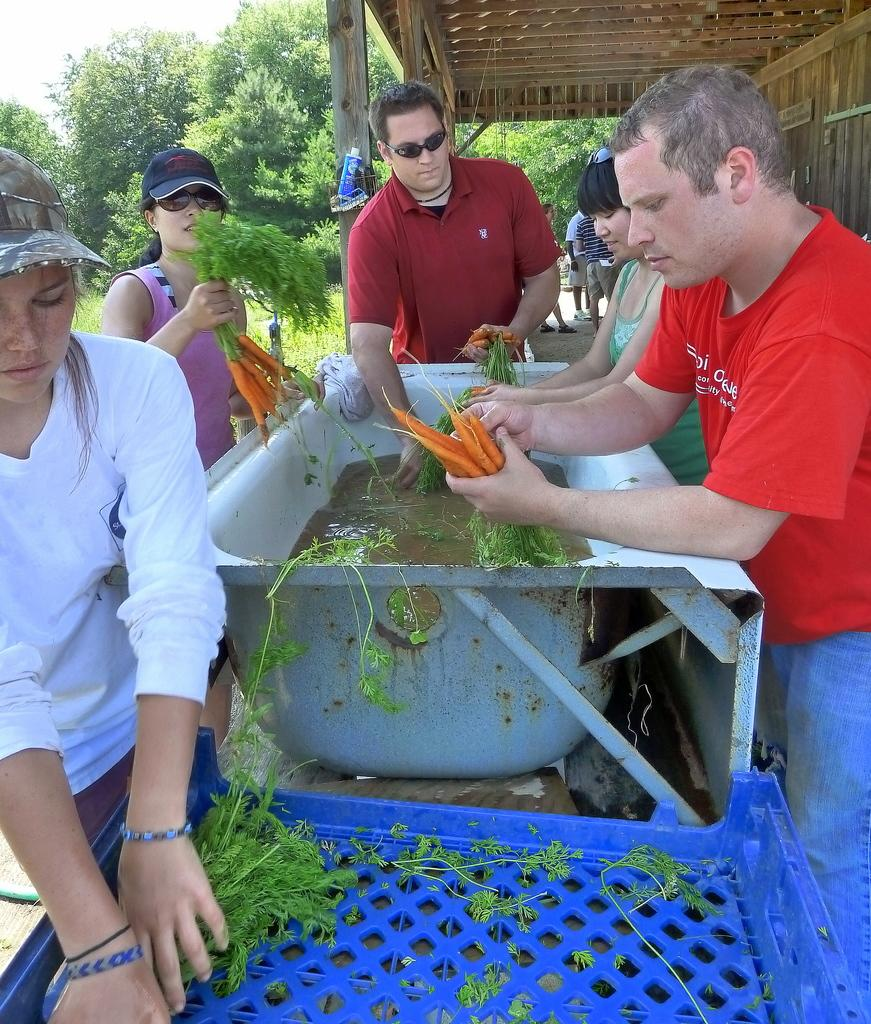Who or what is present in the image? There are people in the image. What are some of the people holding? Some of the people are holding carrots. What can be seen in the background of the image? There is a tree in the background of the image. Are there any fairies visible in the image? There are no fairies present in the image. What type of lace can be seen on the people's clothing in the image? There is no lace visible on the people's clothing in the image. 